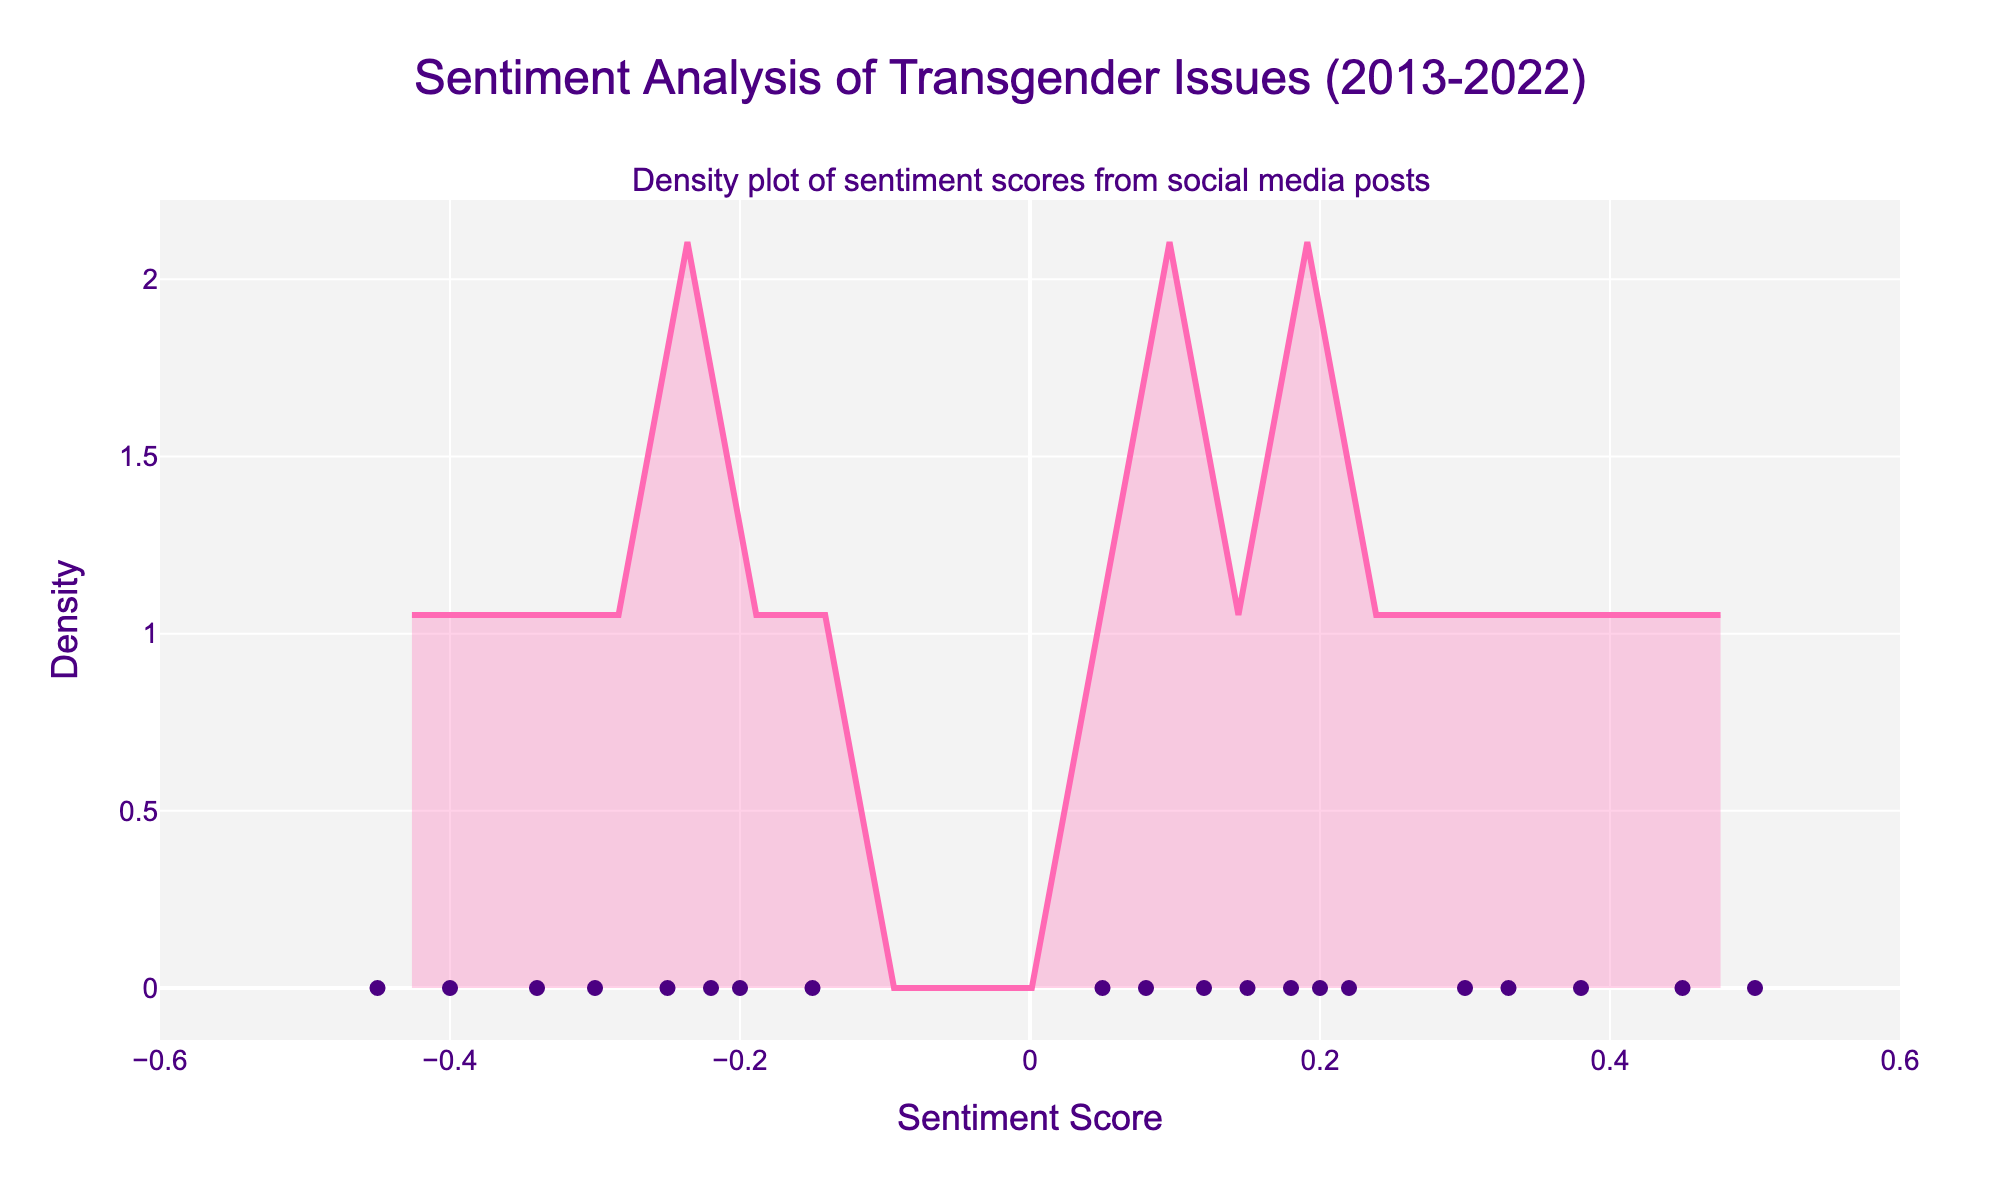What is the title of the figure? The title of the plot is generally located at the top or center of the figure. In this case, the title text is designed to be at the top and center, describing the main theme of the plot.
Answer: Sentiment Analysis of Transgender Issues (2013-2022) What is the range of the x-axis? The x-axis range can typically be observed by looking at the minimum and maximum values shown along the x-axis. Here, the x-axis is specifically set to cover a range from -0.6 to 0.6.
Answer: -0.6 to 0.6 What feature is represented by the density curve? The density curve in a plot like this represents the distribution of the sentiment scores, where the height of the curve at a particular sentiment score reflects its frequency relative to other scores.
Answer: Distribution of sentiment scores Are there more positive or negative sentiment scores displayed? By analyzing the number of points scattered above the x-axis at positive scores vs. negative scores, one can infer that there appear to be slightly more data points on the positive side (right) than the negative side.
Answer: More positive sentiment scores What color are the data points in the scatter plot? The color of the data points can be identified by observing their appearance on the plot. Here, the data points are styled in a distinct color making them easily recognizable.
Answer: Purple What is the approximate highest density value on the plot? The highest peak of the density curve represents the maximum density value. Observing where the curve reaches its highest point on the y-axis provides this value.
Answer: Approx. 1.5 How does the density peak compare between positive and negative sentiment scores? To compare the density peaks, look at the heights of the highest points of the density curve in both the negative and positive sections of the x-axis.
Answer: The peak is higher for positive sentiment scores What is the sentiment score with the lowest frequency? The lowest frequency is represented by the least height of the density curve, which appears at sentiment scores where the curve is closest to the x-axis. Identifying these regions on the curve helps to determine the least frequent sentiment scores.
Answer: Sentiment scores around -0.5 Is there a larger spread in positive or negative sentiment scores? To determine the spread, observe the width of the density curve on both sides of the x-axis, considering how far the curve extends from the center in both the positive and negative directions.
Answer: Positive sentiment scores What is the significance of the scatter points plotted along the x-axis? The scatter points represent individual data points of different sentiment scores. They provide a visual indication of where each individual sentiment score lies on the sentiment spectrum, adding detail to the distribution shown by the density curve.
Answer: Individual sentiment scores 